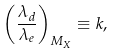<formula> <loc_0><loc_0><loc_500><loc_500>\left ( \frac { \lambda _ { d } } { \lambda _ { e } } \right ) _ { M _ { X } } \equiv k ,</formula> 